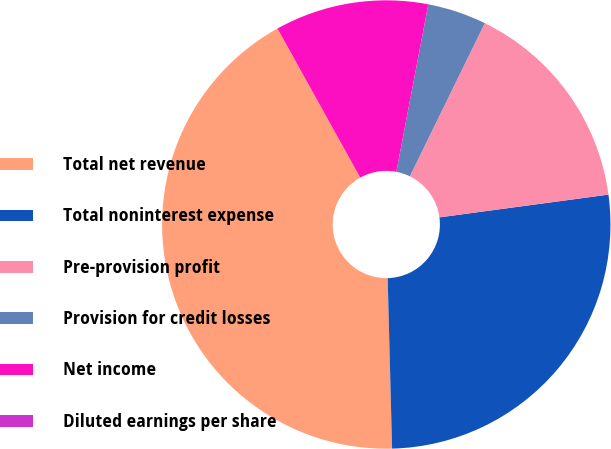Convert chart. <chart><loc_0><loc_0><loc_500><loc_500><pie_chart><fcel>Total net revenue<fcel>Total noninterest expense<fcel>Pre-provision profit<fcel>Provision for credit losses<fcel>Net income<fcel>Diluted earnings per share<nl><fcel>42.35%<fcel>26.72%<fcel>15.63%<fcel>4.24%<fcel>11.07%<fcel>0.0%<nl></chart> 